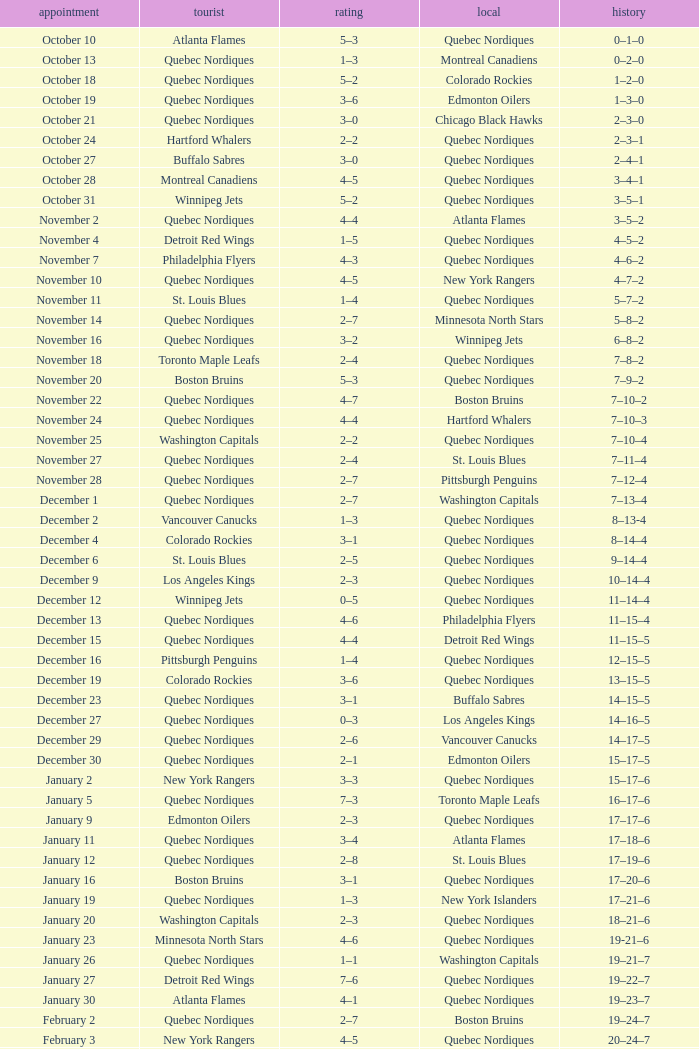Which Date has a Score of 2–7, and a Record of 5–8–2? November 14. 